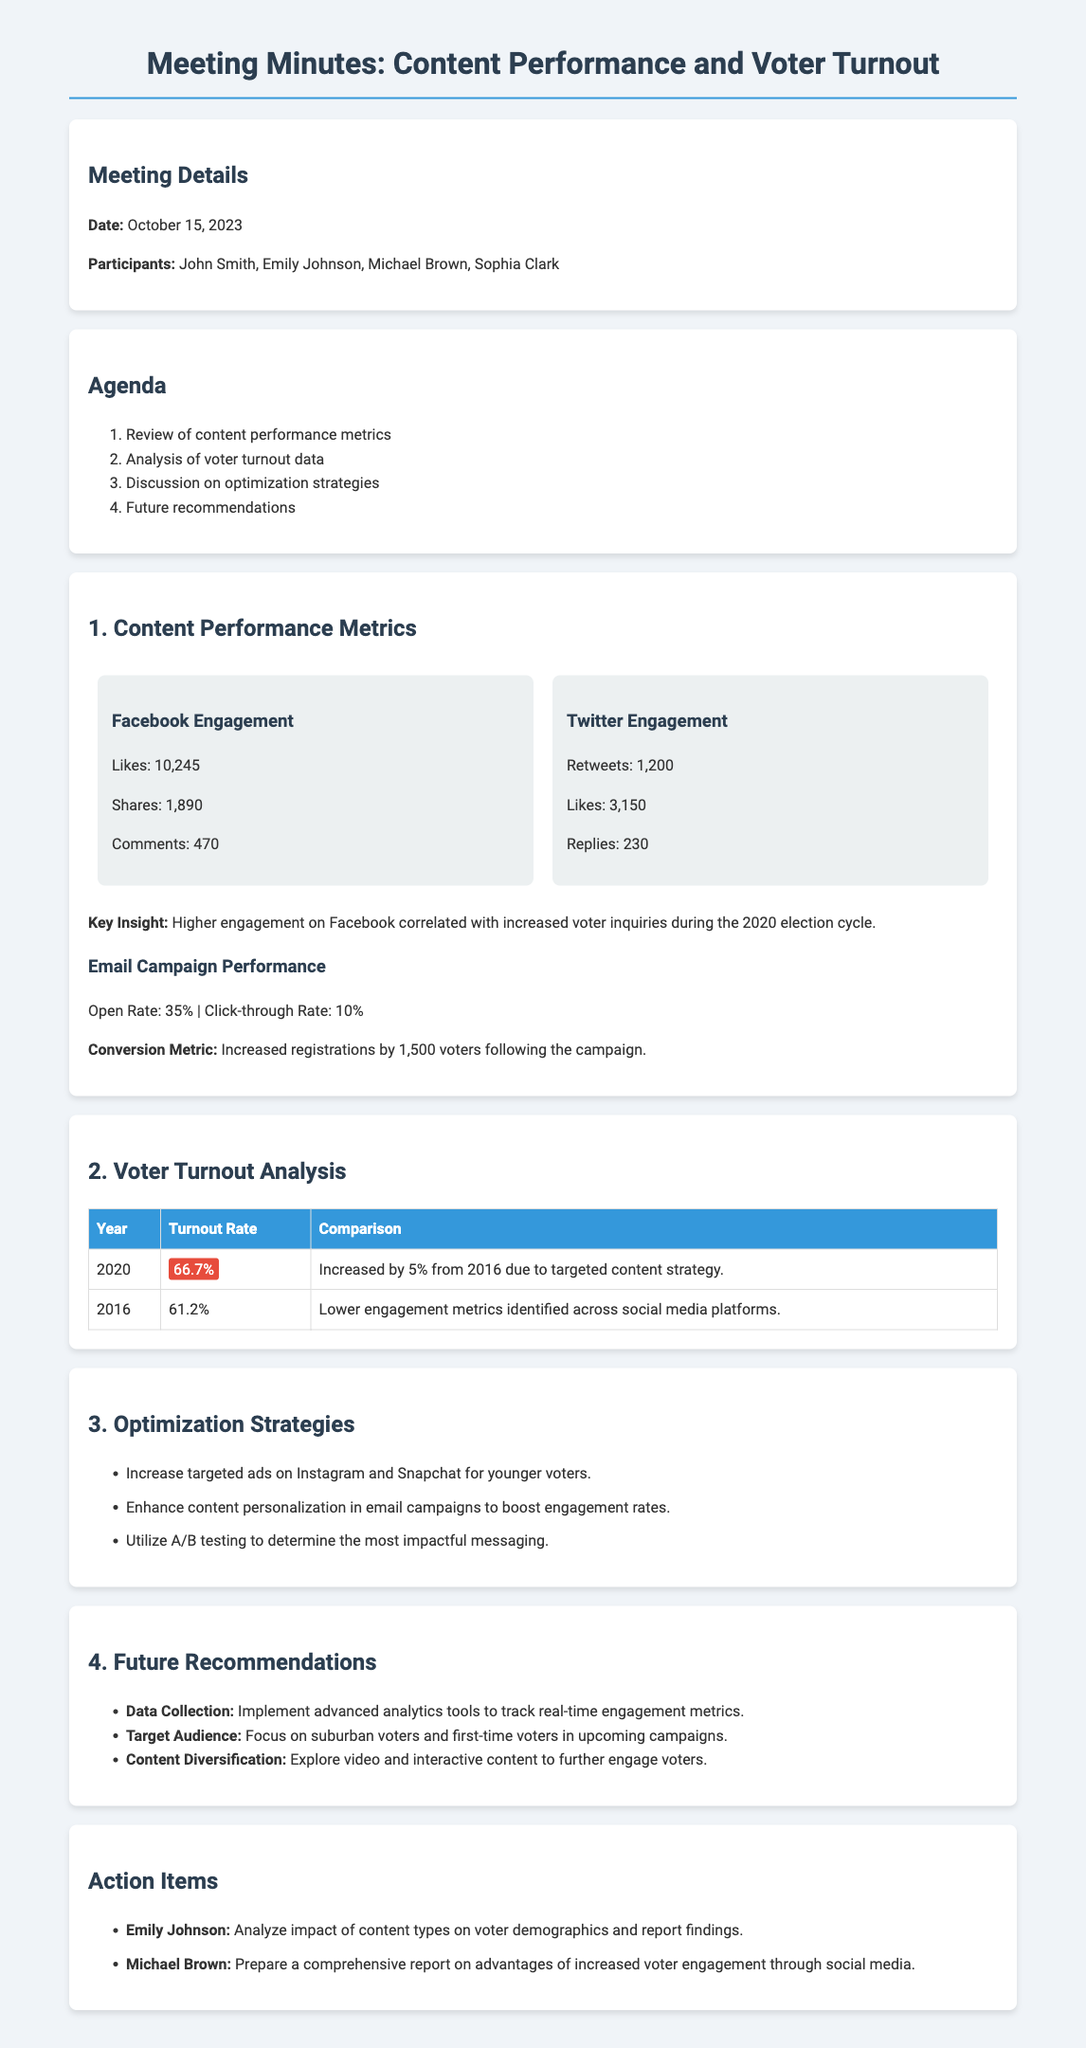What was the date of the meeting? The date is mentioned in the "Meeting Details" section of the document.
Answer: October 15, 2023 Who were the participants in the meeting? The participants are listed in the "Meeting Details" section.
Answer: John Smith, Emily Johnson, Michael Brown, Sophia Clark What was the Facebook Likes count? The Facebook engagement metrics are discussed, and Likes are specified.
Answer: 10,245 What is the voter turnout rate for 2020? The voter turnout rates for different years are presented in the table under "Voter Turnout Analysis."
Answer: 66.7% What key insight was drawn from the content performance metrics? The key insight is provided at the end of the "Content Performance Metrics" section.
Answer: Higher engagement on Facebook correlated with increased voter inquiries during the 2020 election cycle Which social media platform is recommended for targeting younger voters? Recommendations on optimization strategies mention targeting particular platforms.
Answer: Instagram and Snapchat What is one of the future recommendations about content? Future recommendations include specific suggestions on content types to improve voter engagement.
Answer: Explore video and interactive content to further engage voters Who is responsible for analyzing the impact of content types on voter demographics? The action items section specifies who is responsible for this task.
Answer: Emily Johnson What was the conversion metric from the email campaign? The email campaign performance includes a specific conversion metric.
Answer: Increased registrations by 1,500 voters following the campaign 